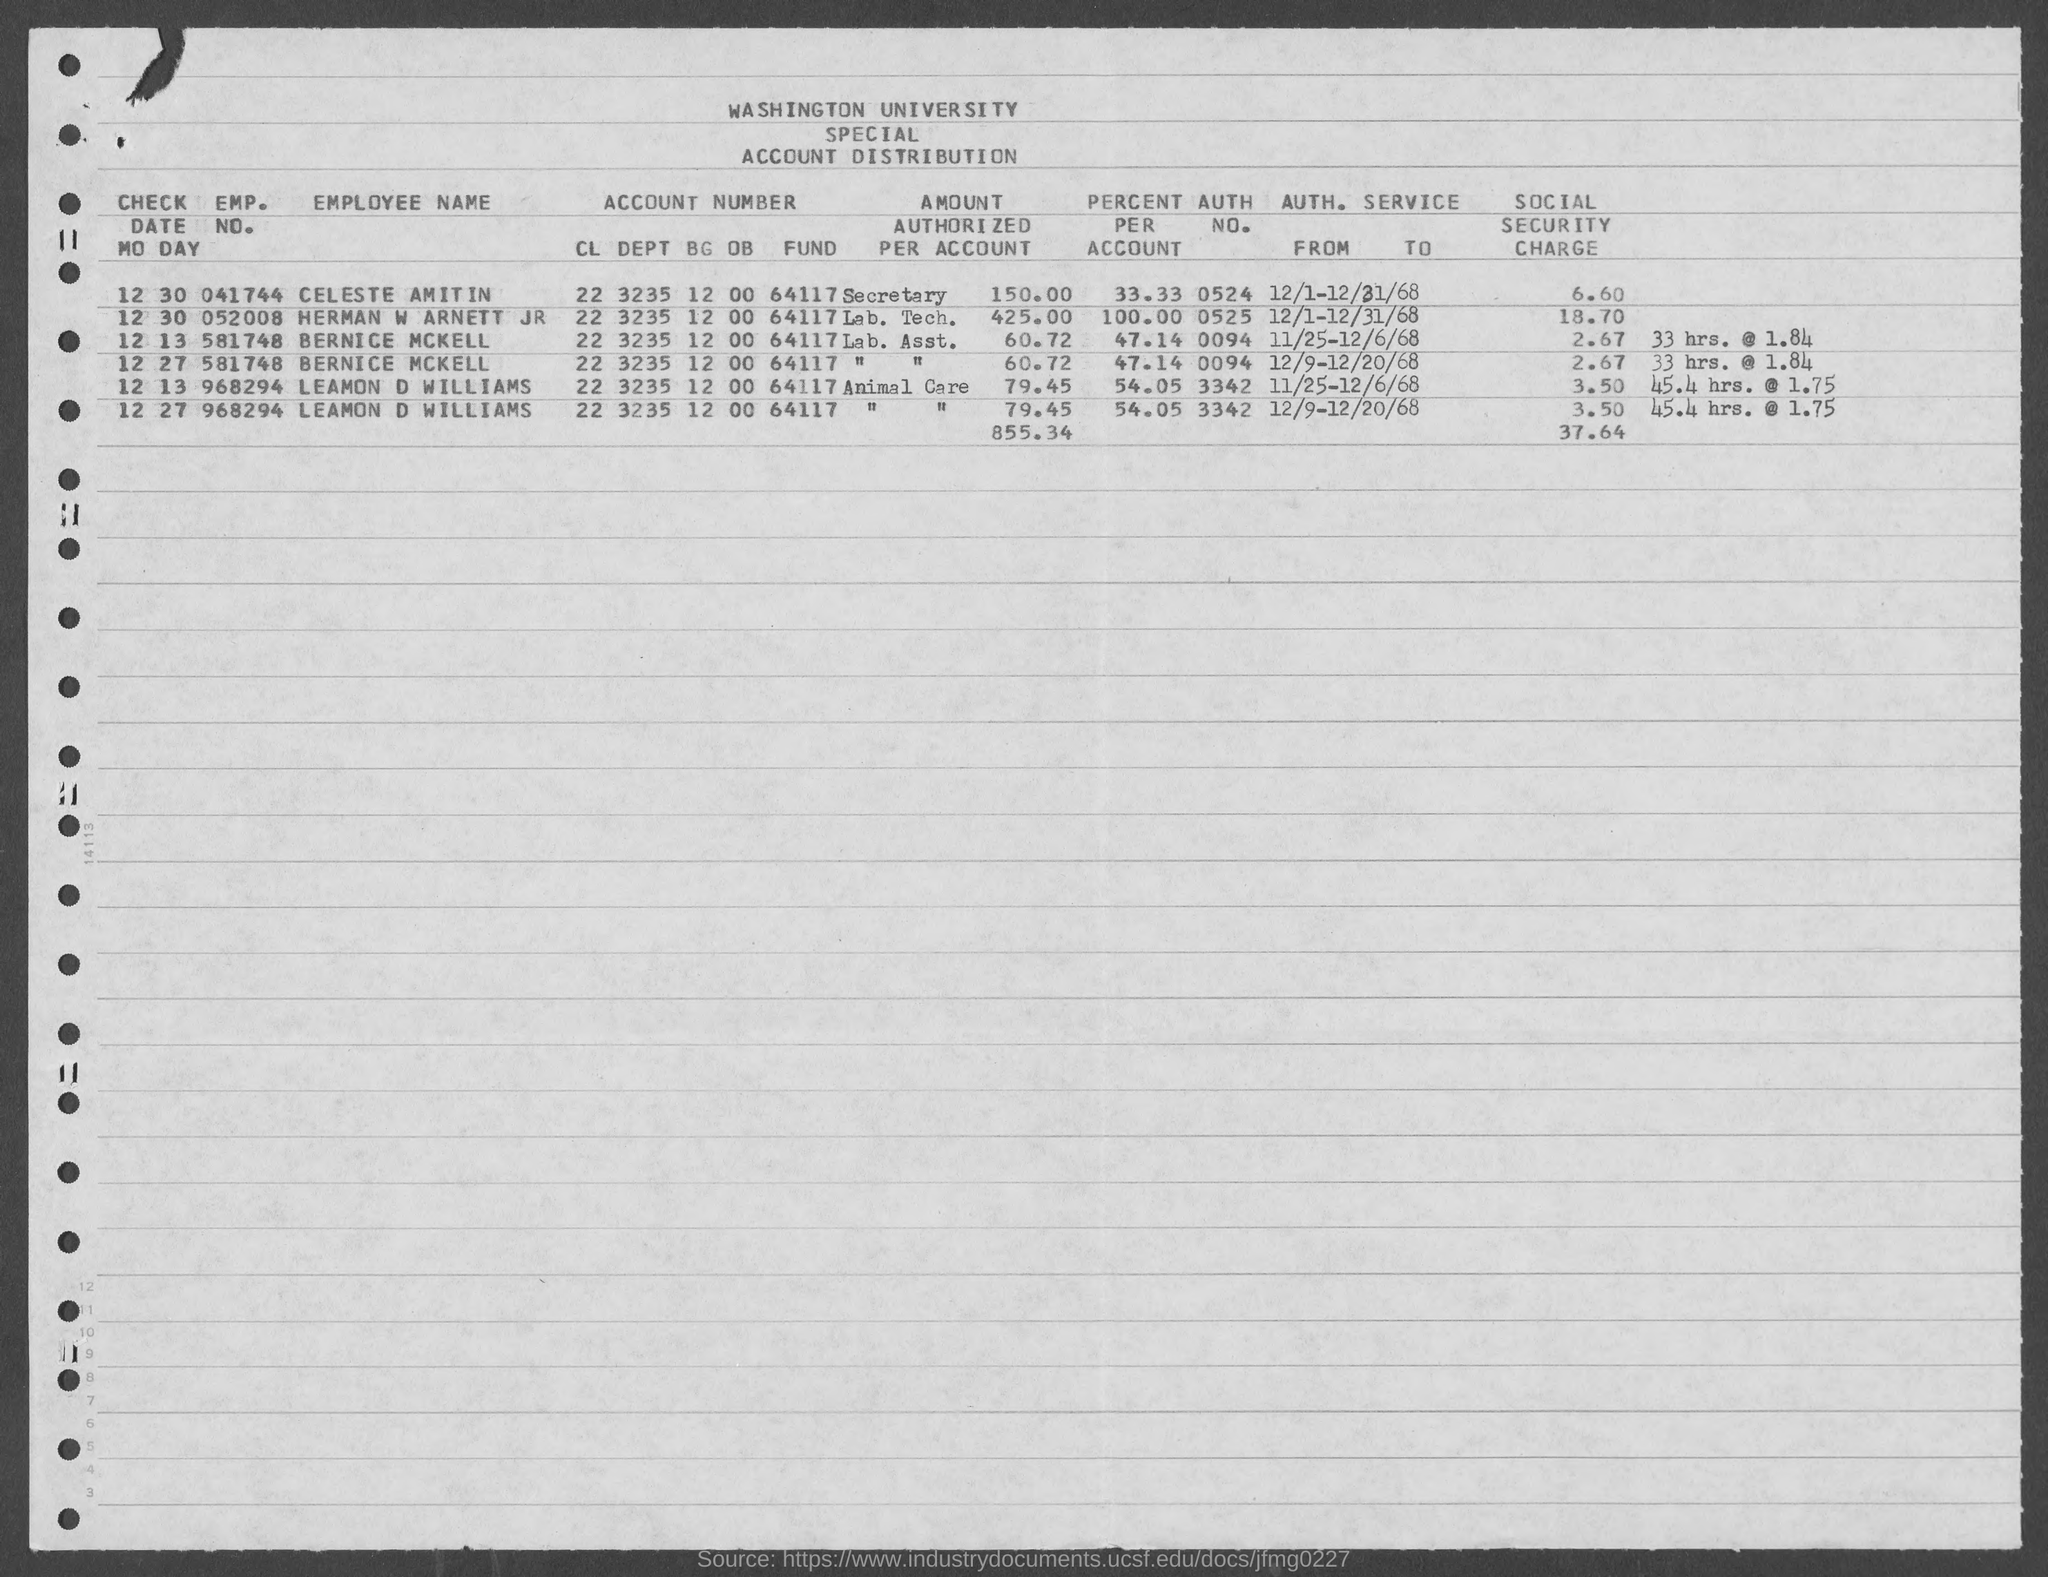Draw attention to some important aspects in this diagram. The value of percent per account for Leamon D. Williams, as mentioned in the given form, is 54.05%. The inquiry seeks to know the authentication number of Bernice McKell, which can be represented as 0094... The emp. no. of Bernice McKell mentioned in the given form is 581748... The identity number of Celeste Amitin is 041744. The authorization number of Lemon D. Williams is 3342. 